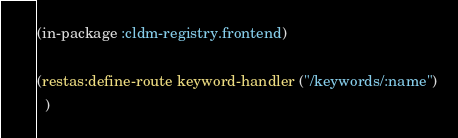<code> <loc_0><loc_0><loc_500><loc_500><_Lisp_>(in-package :cldm-registry.frontend)

(restas:define-route keyword-handler ("/keywords/:name")
  )
</code> 